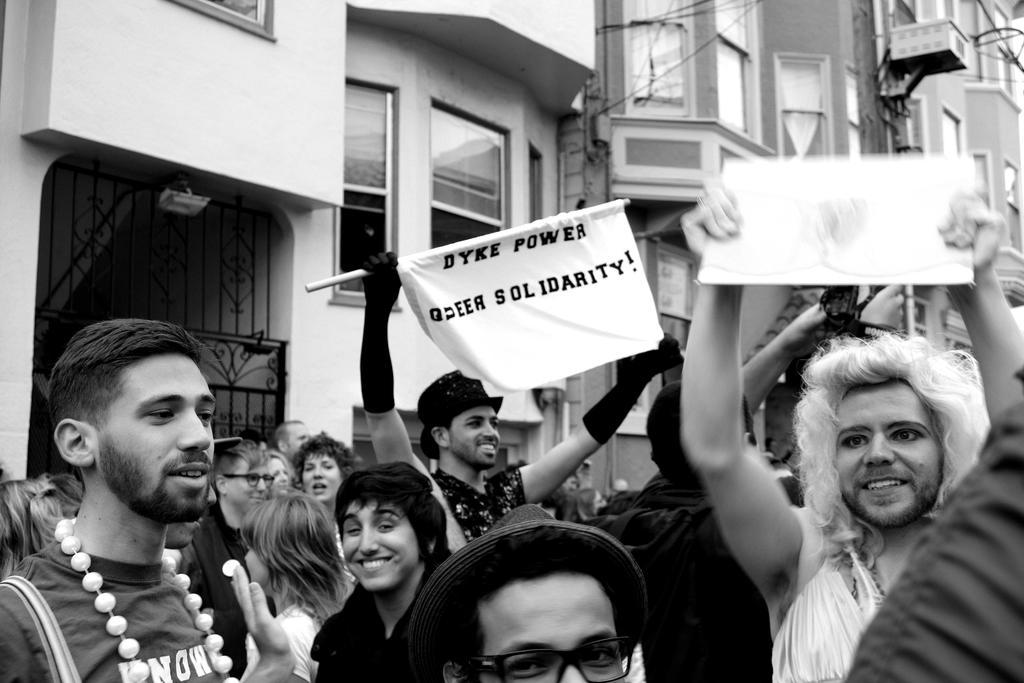In one or two sentences, can you explain what this image depicts? This is a black and white picture. On the left side of the picture we can see buildings, windows and a gate. We can see people and few are holding banners. 